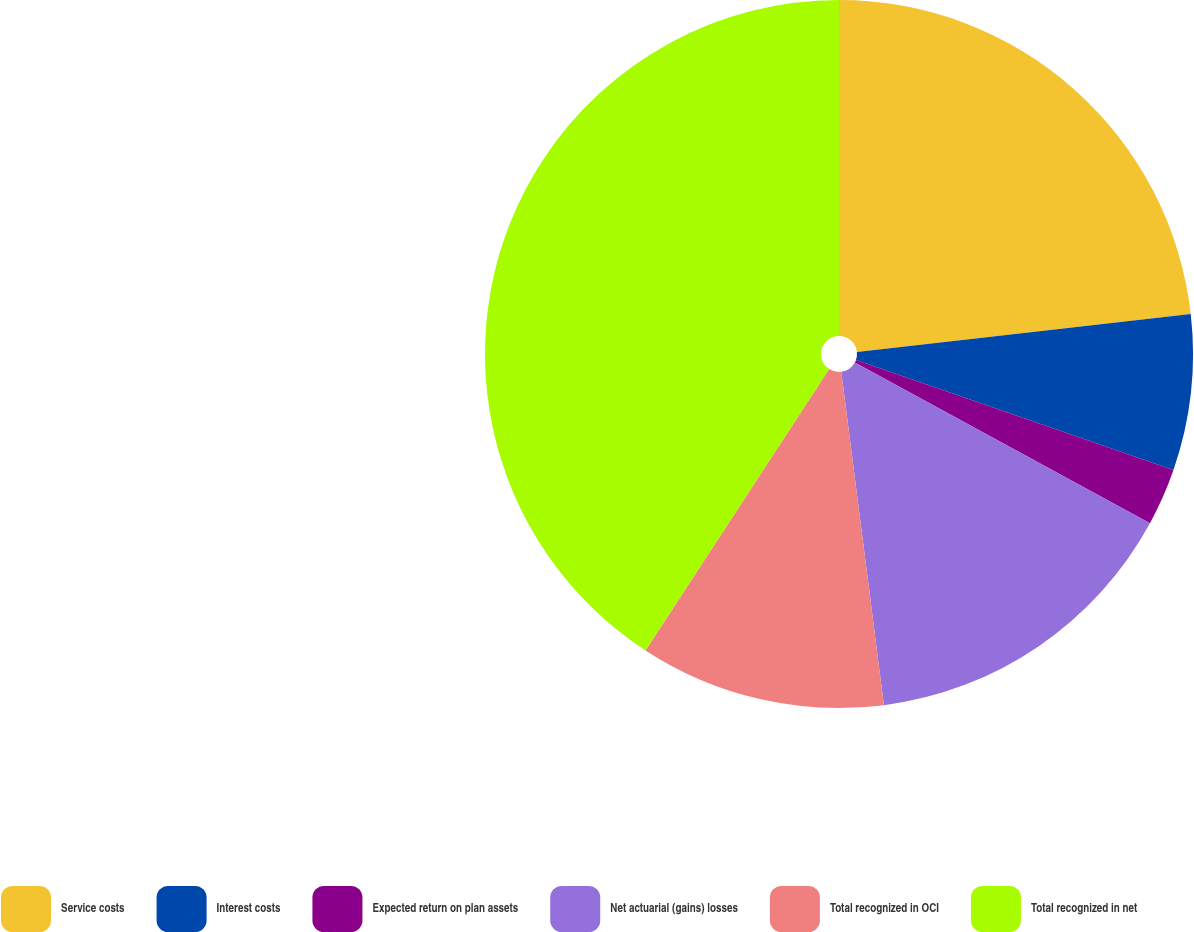Convert chart. <chart><loc_0><loc_0><loc_500><loc_500><pie_chart><fcel>Service costs<fcel>Interest costs<fcel>Expected return on plan assets<fcel>Net actuarial (gains) losses<fcel>Total recognized in OCI<fcel>Total recognized in net<nl><fcel>23.2%<fcel>7.11%<fcel>2.62%<fcel>15.04%<fcel>11.23%<fcel>40.79%<nl></chart> 